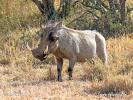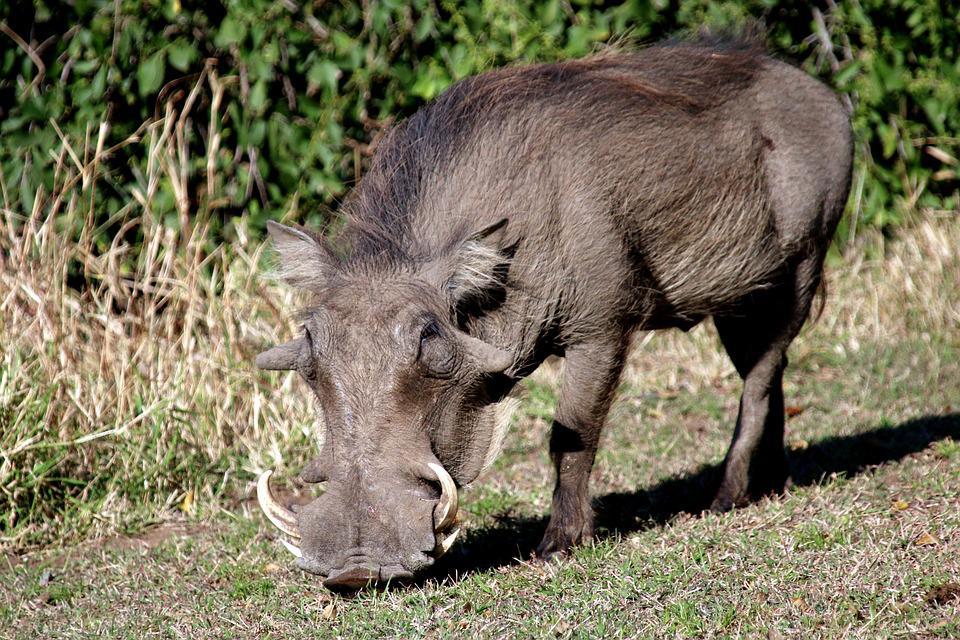The first image is the image on the left, the second image is the image on the right. Examine the images to the left and right. Is the description "The hog on the right has it's mouth on the ground." accurate? Answer yes or no. Yes. 